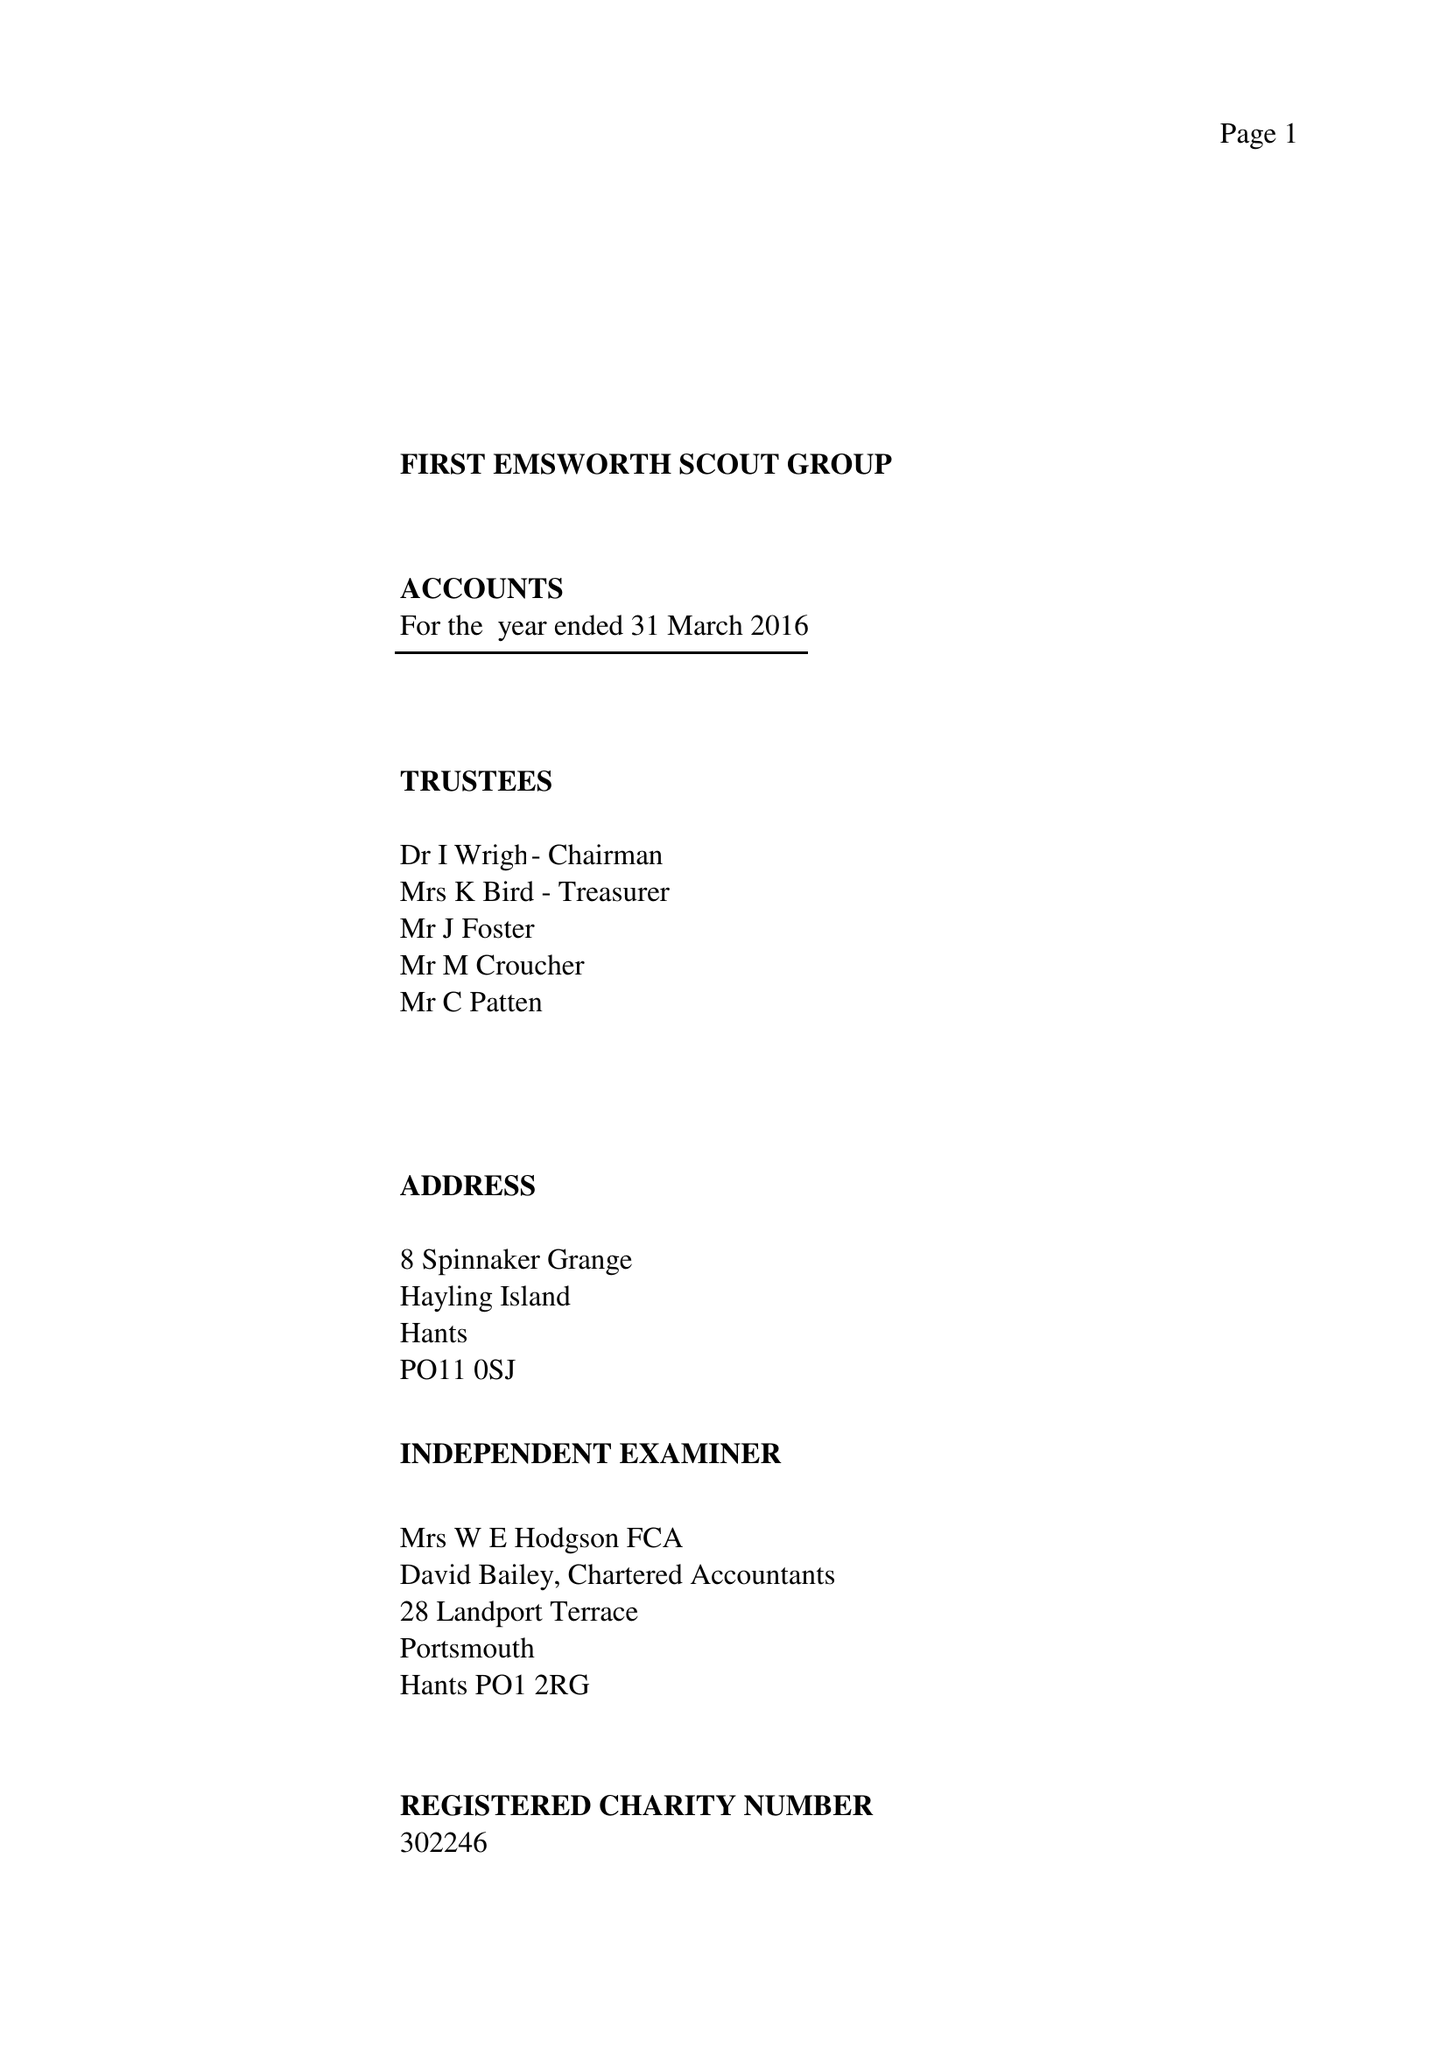What is the value for the income_annually_in_british_pounds?
Answer the question using a single word or phrase. 29051.00 